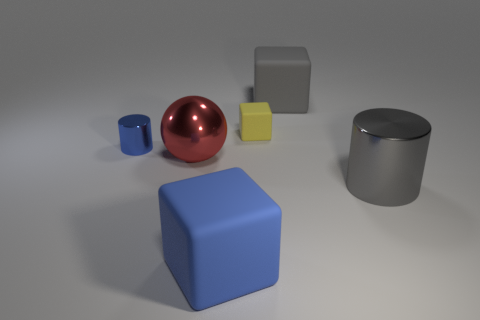What is the cylinder that is behind the thing right of the big cube on the right side of the small yellow matte object made of?
Provide a short and direct response. Metal. Do the blue cylinder and the rubber block that is in front of the yellow thing have the same size?
Your answer should be very brief. No. There is another thing that is the same shape as the tiny blue shiny thing; what material is it?
Your response must be concise. Metal. There is a metallic cylinder that is to the left of the big blue matte object that is in front of the large rubber object that is behind the large red metal sphere; what size is it?
Your answer should be very brief. Small. Is the size of the ball the same as the blue rubber thing?
Your answer should be very brief. Yes. There is a big gray thing behind the tiny thing that is on the left side of the large ball; what is it made of?
Keep it short and to the point. Rubber. Is the shape of the rubber object in front of the gray shiny cylinder the same as the big object that is on the left side of the large blue matte cube?
Your answer should be compact. No. Is the number of red metal things that are behind the small cube the same as the number of big brown blocks?
Your response must be concise. Yes. There is a object that is on the left side of the metallic ball; is there a matte block that is in front of it?
Your response must be concise. Yes. Is there any other thing of the same color as the metallic ball?
Ensure brevity in your answer.  No. 